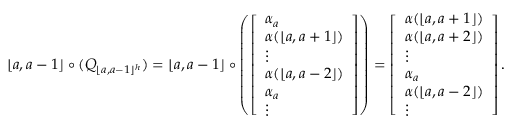Convert formula to latex. <formula><loc_0><loc_0><loc_500><loc_500>\lfloor a , a - 1 \rfloor \circ ( Q _ { \lfloor a , a - 1 \rfloor ^ { h } } ) = \lfloor a , a - 1 \rfloor \circ \left ( \left [ \begin{array} { l } { \alpha _ { a } } \\ { \alpha ( \lfloor a , a + 1 \rfloor ) } \\ { \vdots } \\ { \alpha ( \lfloor a , a - 2 \rfloor ) } \\ { \alpha _ { a } } \\ { \vdots } \end{array} \right ] \right ) = \left [ \begin{array} { l } { \alpha ( \lfloor a , a + 1 \rfloor ) } \\ { \alpha ( \lfloor a , a + 2 \rfloor ) } \\ { \vdots } \\ { \alpha _ { a } } \\ { \alpha ( \lfloor a , a - 2 \rfloor ) } \\ { \vdots } \end{array} \right ] .</formula> 